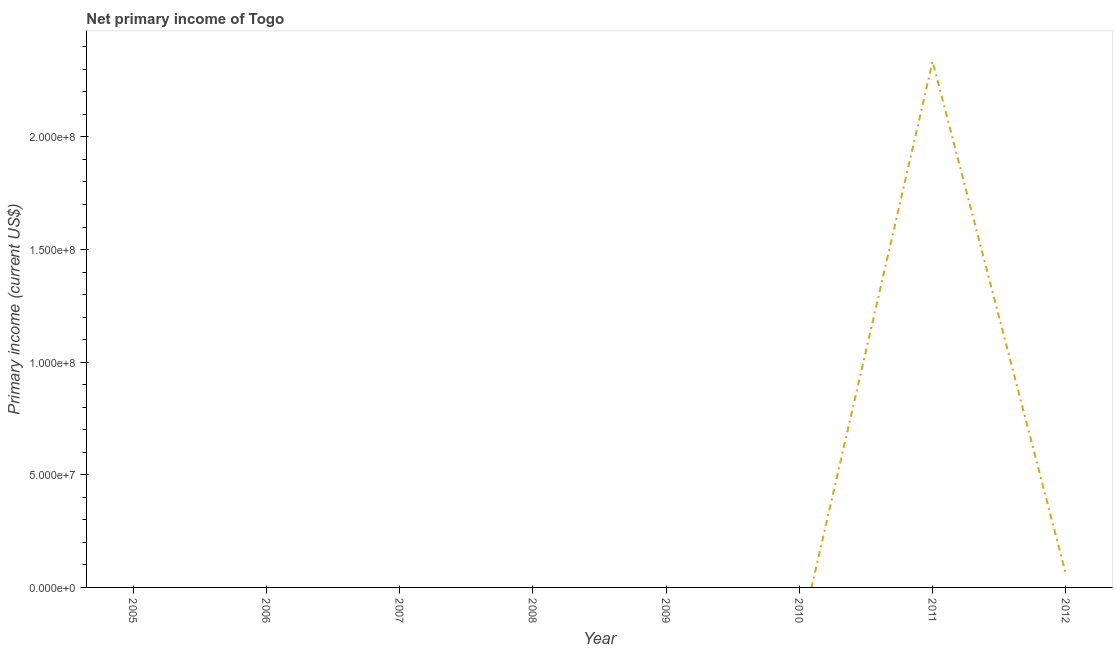What is the amount of primary income in 2008?
Give a very brief answer. 0. Across all years, what is the maximum amount of primary income?
Offer a very short reply. 2.34e+08. Across all years, what is the minimum amount of primary income?
Provide a short and direct response. 0. In which year was the amount of primary income maximum?
Keep it short and to the point. 2011. What is the sum of the amount of primary income?
Offer a very short reply. 2.40e+08. What is the average amount of primary income per year?
Offer a very short reply. 2.99e+07. What is the median amount of primary income?
Your answer should be very brief. 0. In how many years, is the amount of primary income greater than 100000000 US$?
Make the answer very short. 1. What is the difference between the highest and the lowest amount of primary income?
Your answer should be compact. 2.34e+08. In how many years, is the amount of primary income greater than the average amount of primary income taken over all years?
Your response must be concise. 1. How many lines are there?
Provide a succinct answer. 1. What is the difference between two consecutive major ticks on the Y-axis?
Provide a short and direct response. 5.00e+07. Does the graph contain any zero values?
Provide a succinct answer. Yes. Does the graph contain grids?
Give a very brief answer. No. What is the title of the graph?
Offer a terse response. Net primary income of Togo. What is the label or title of the Y-axis?
Provide a succinct answer. Primary income (current US$). What is the Primary income (current US$) of 2006?
Your answer should be very brief. 0. What is the Primary income (current US$) in 2008?
Offer a terse response. 0. What is the Primary income (current US$) in 2009?
Provide a short and direct response. 0. What is the Primary income (current US$) in 2011?
Provide a short and direct response. 2.34e+08. What is the Primary income (current US$) in 2012?
Ensure brevity in your answer.  5.98e+06. What is the difference between the Primary income (current US$) in 2011 and 2012?
Your response must be concise. 2.28e+08. What is the ratio of the Primary income (current US$) in 2011 to that in 2012?
Provide a short and direct response. 39.08. 